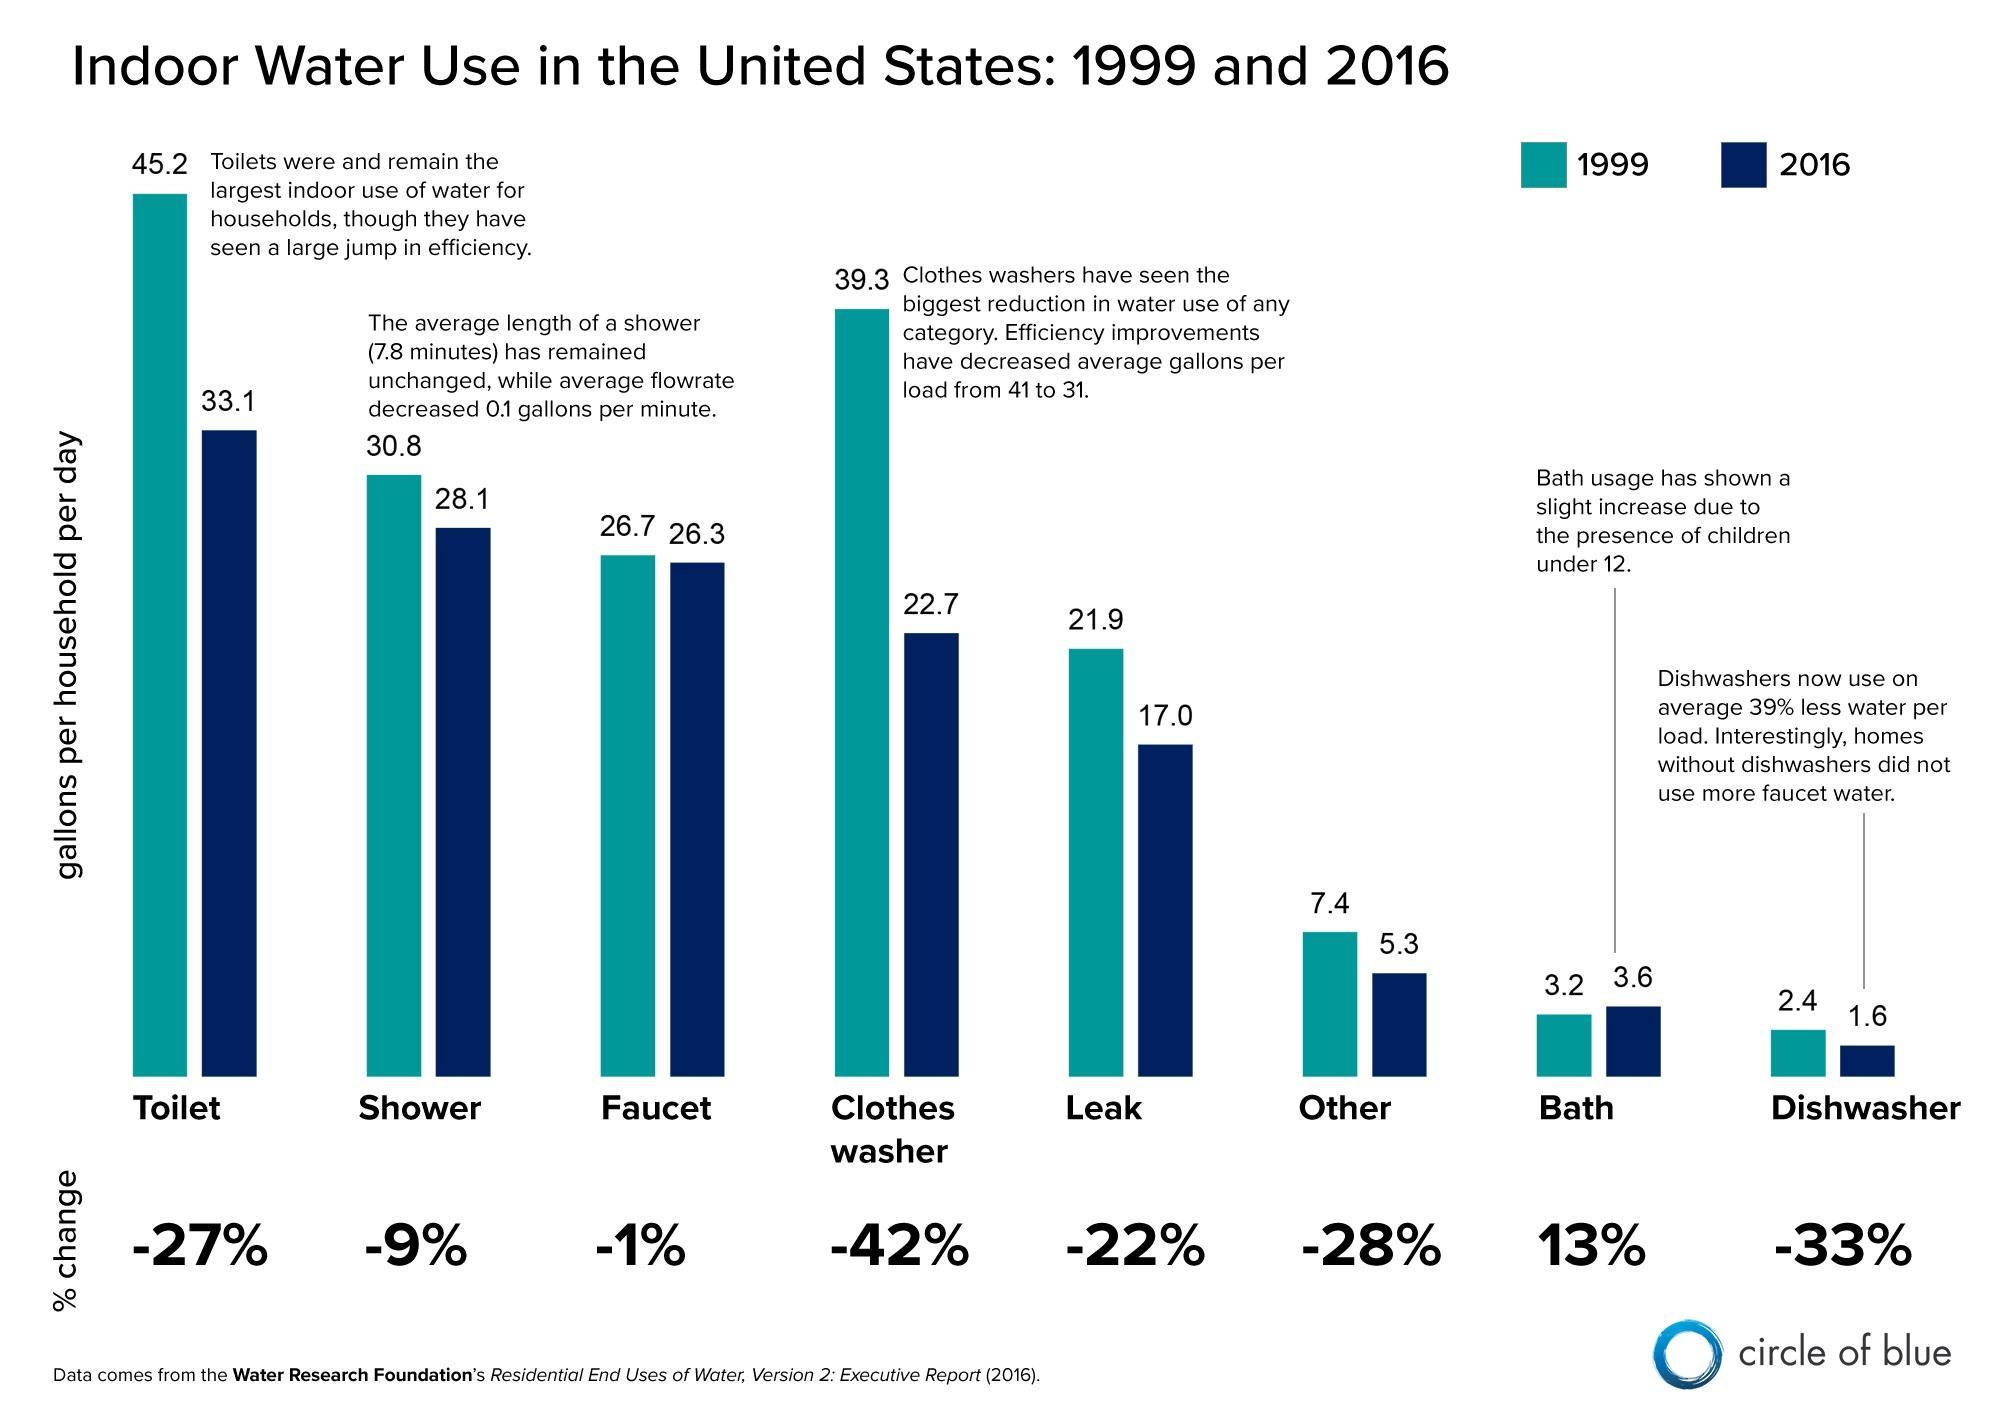what has been the percentage decrease in clothes washer
Answer the question with a short phrase. -42% what is the bath usage in 2016 3.6 what has been the percentage increase in bath 13% what is the leak in 1999 21.9 in which year has bath shown an increase 2016 where is the water consumption the highest in 2016 toilet what has been the second highest decrease as per graph dishwasher 